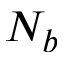Convert formula to latex. <formula><loc_0><loc_0><loc_500><loc_500>N _ { b }</formula> 